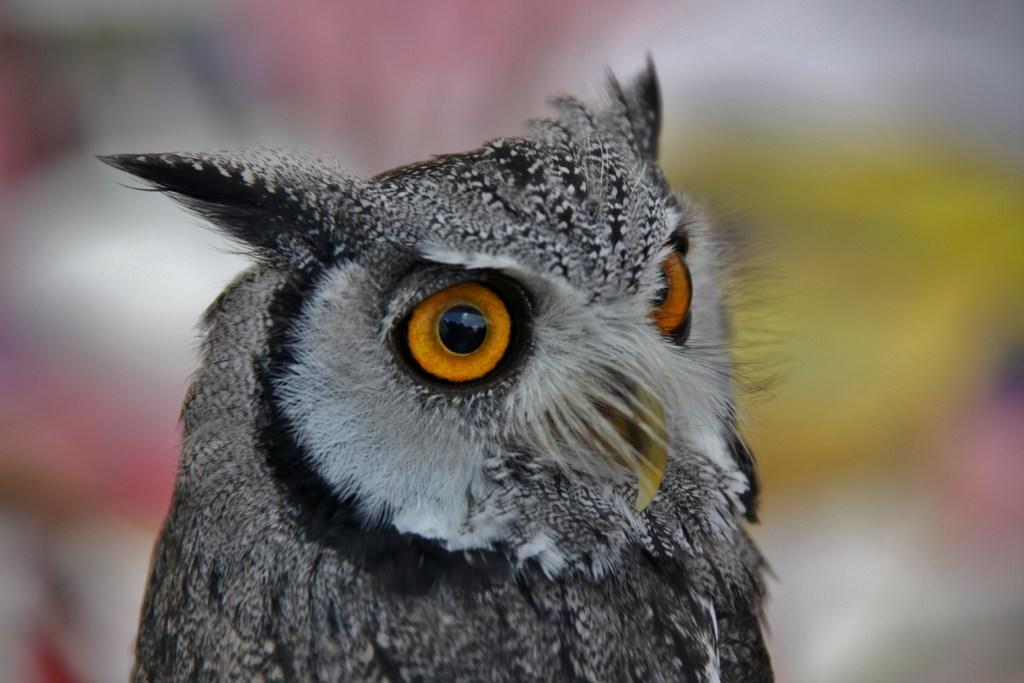What animal is the main subject of the image? There is an owl in the image. Can you describe the background of the image? The background of the image is blurry. What is the tendency of the dock in the image? There is no dock present in the image, so it is not possible to determine any tendencies. 